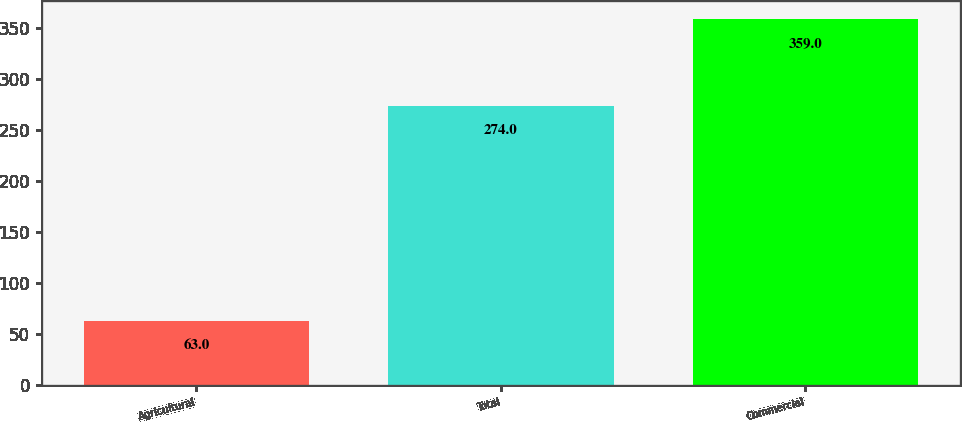Convert chart. <chart><loc_0><loc_0><loc_500><loc_500><bar_chart><fcel>Agricultural<fcel>Total<fcel>Commercial<nl><fcel>63<fcel>274<fcel>359<nl></chart> 